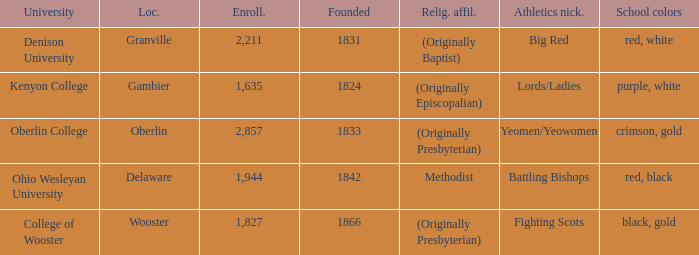What was the religious affiliation for the athletics nicknamed lords/ladies? (Originally Episcopalian). 